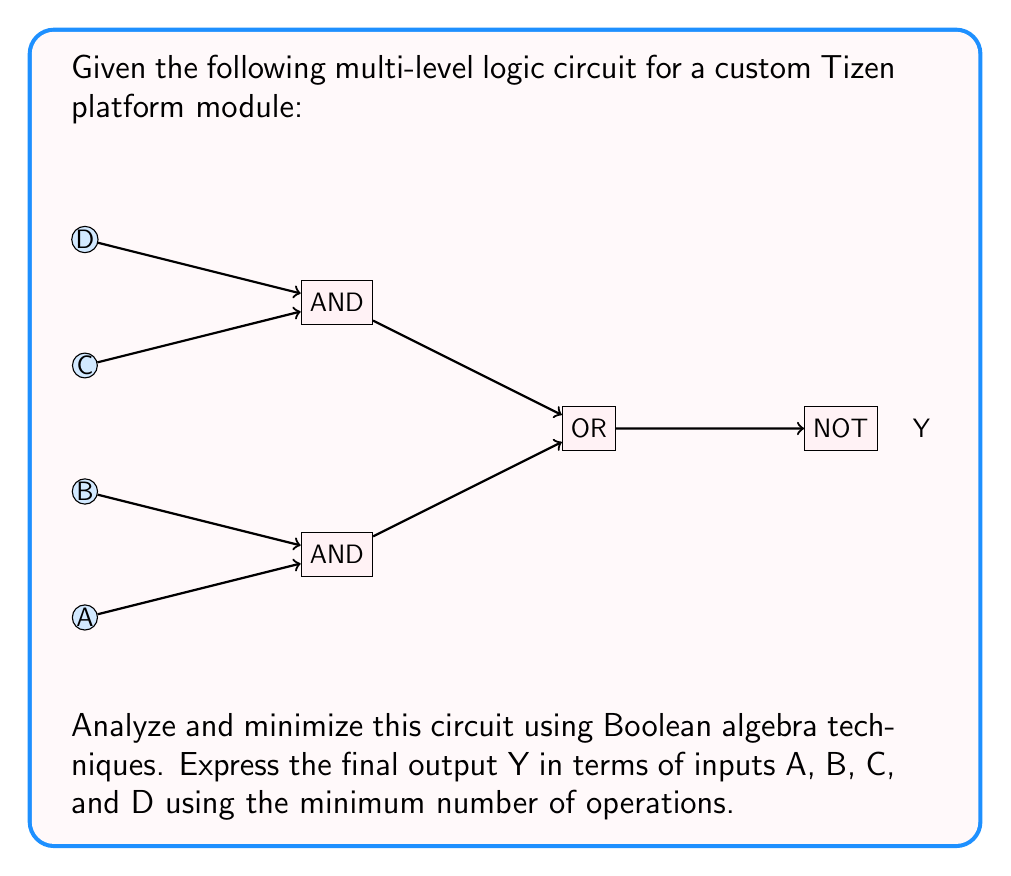Could you help me with this problem? Let's approach this step-by-step:

1) First, let's express the output Y in terms of the intermediate operations:

   $Y = \overline{(A \cdot B) + (C \cdot D)}$

2) We can apply De Morgan's law to distribute the NOT operation:

   $Y = \overline{(A \cdot B)} \cdot \overline{(C \cdot D)}$

3) Applying De Morgan's law again to each term:

   $Y = (\overline{A} + \overline{B}) \cdot (\overline{C} + \overline{D})$

4) Now, let's expand this expression:

   $Y = (\overline{A} \cdot \overline{C}) + (\overline{A} \cdot \overline{D}) + (\overline{B} \cdot \overline{C}) + (\overline{B} \cdot \overline{D})$

5) This expression is already in its simplest form (sum of products). We can't further reduce it using Boolean algebra techniques.

6) However, we can rewrite it to minimize the number of operations:

   $Y = \overline{A} \cdot (\overline{C} + \overline{D}) + \overline{B} \cdot (\overline{C} + \overline{D})$

   This form uses 5 operations (2 ANDs, 2 ORs, 1 OR) instead of 7 in the expanded form.

7) We can further optimize by factoring out the common term:

   $Y = (\overline{A} + \overline{B}) \cdot (\overline{C} + \overline{D})$

This final form uses only 3 operations (2 ORs, 1 AND), which is the minimum possible for this circuit.
Answer: $Y = (\overline{A} + \overline{B}) \cdot (\overline{C} + \overline{D})$ 